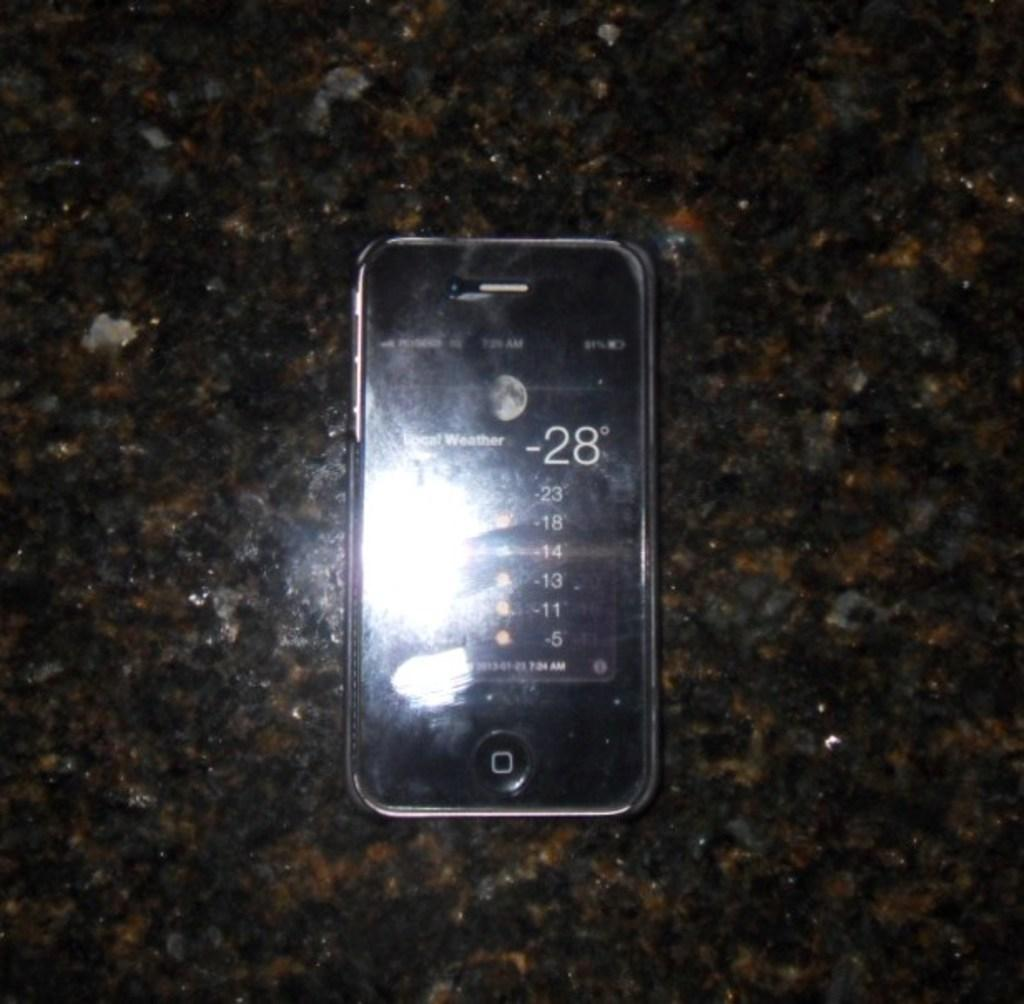<image>
Give a short and clear explanation of the subsequent image. The temperature displayed on the cell phone is -28 degrees 